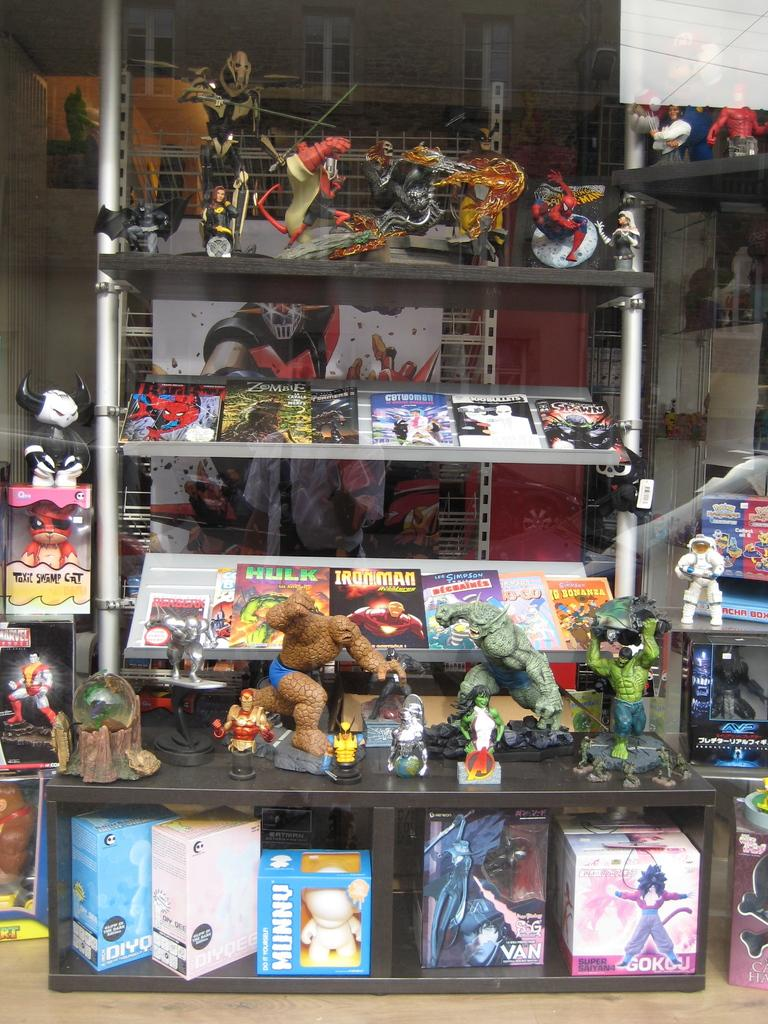<image>
Share a concise interpretation of the image provided. a shelving unit with a bunch of different super hero toys including hulk, ironman, and a mummy at the bottom 